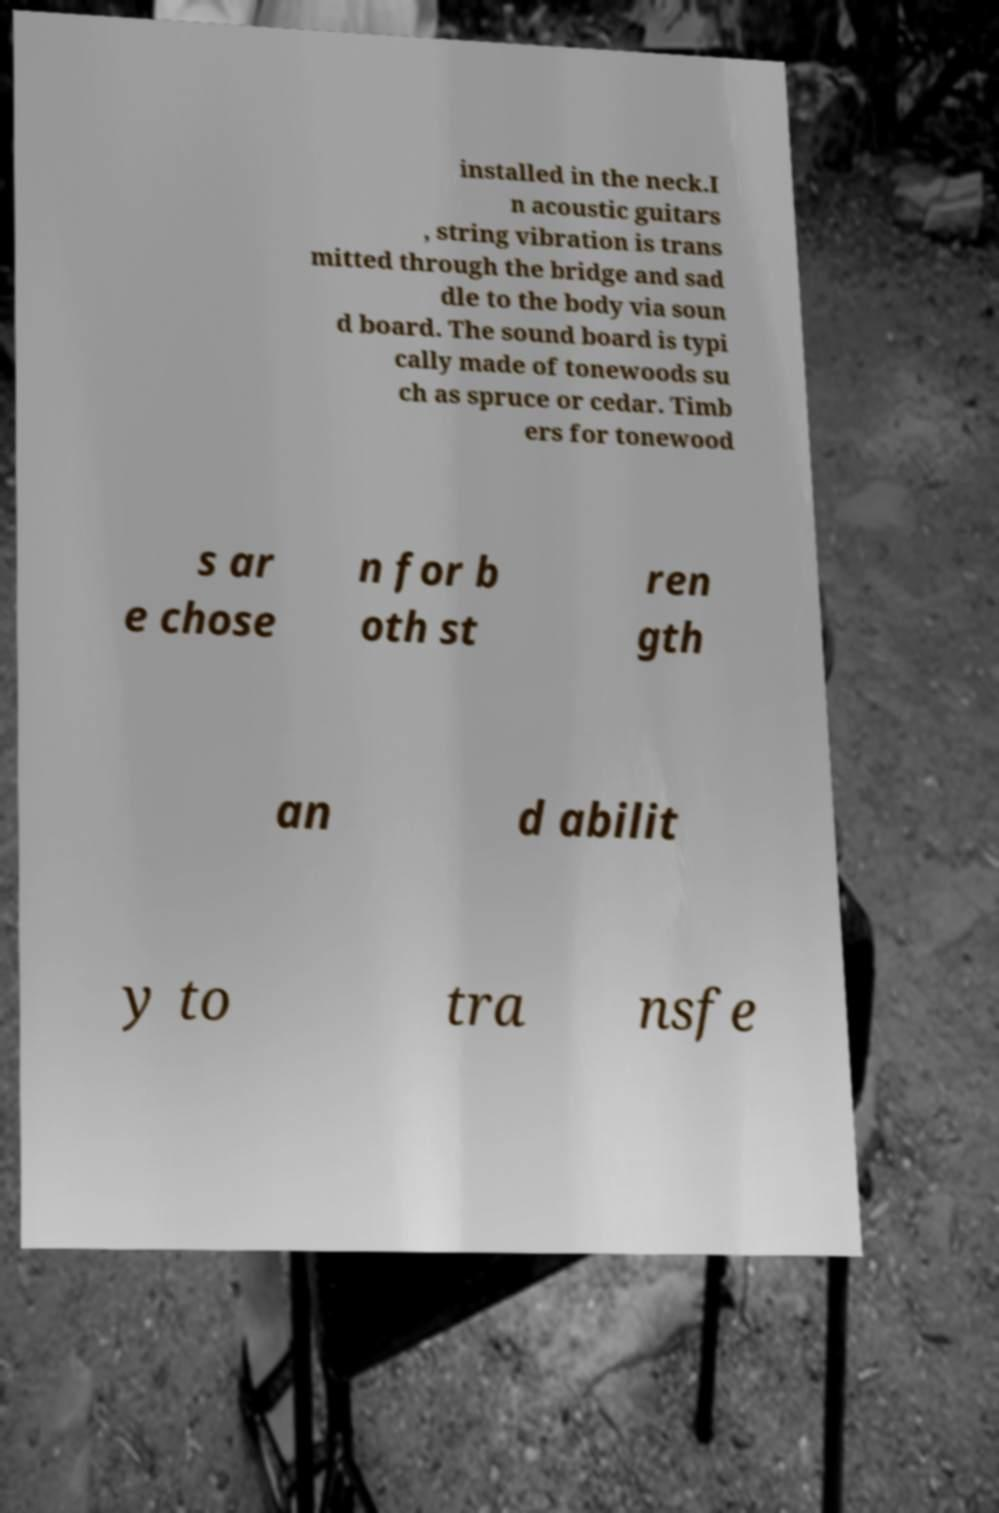Please read and relay the text visible in this image. What does it say? installed in the neck.I n acoustic guitars , string vibration is trans mitted through the bridge and sad dle to the body via soun d board. The sound board is typi cally made of tonewoods su ch as spruce or cedar. Timb ers for tonewood s ar e chose n for b oth st ren gth an d abilit y to tra nsfe 